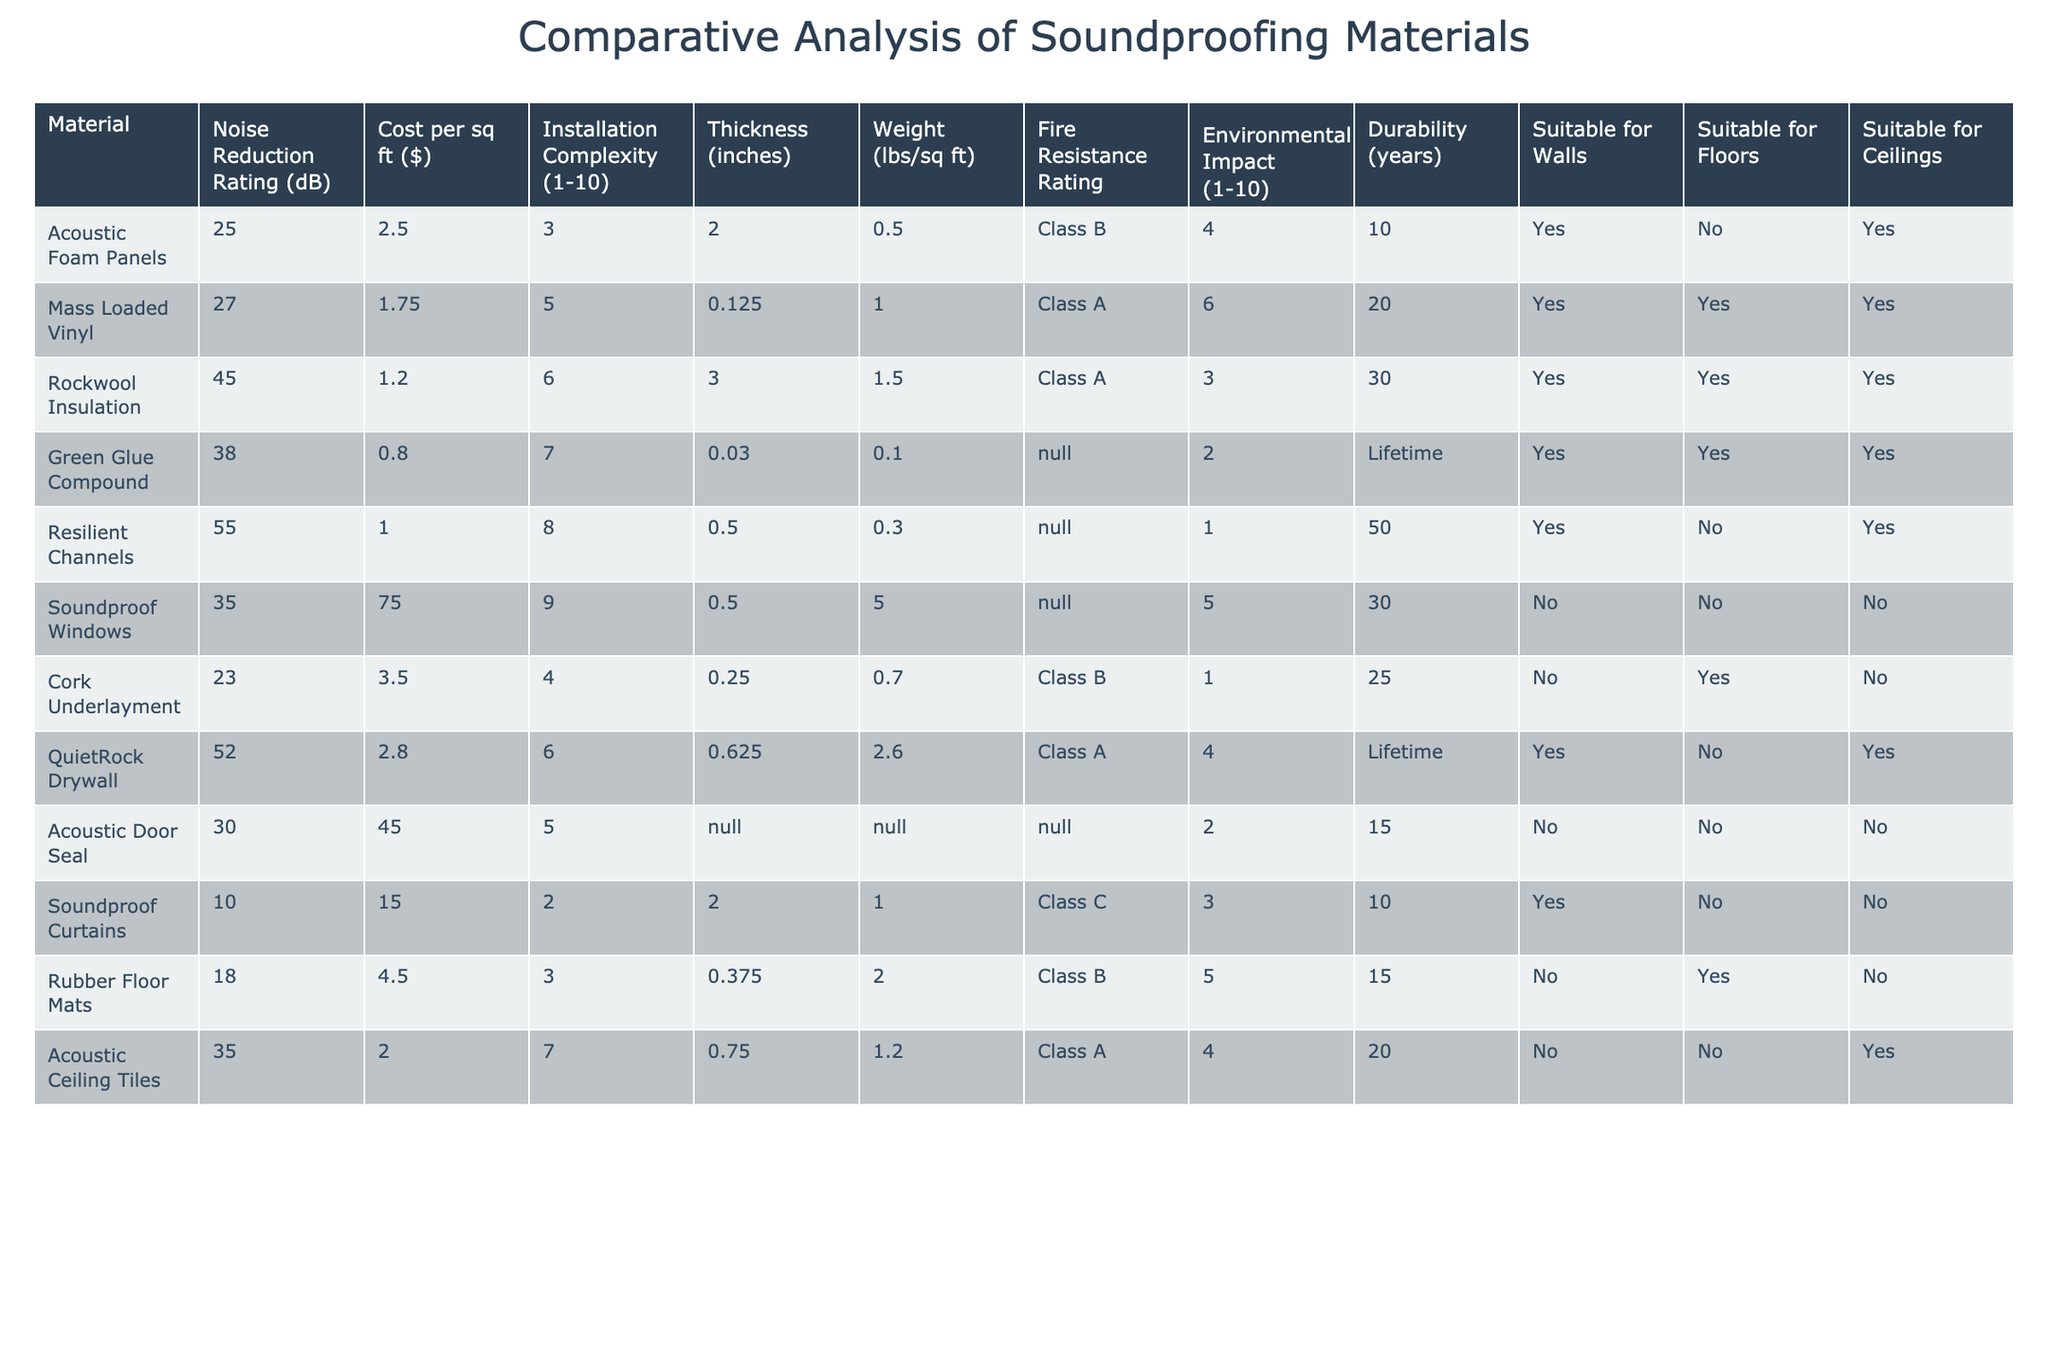What is the Noise Reduction Rating for Rockwool Insulation? The Noise Reduction Rating is listed directly in the table under Rockwool Insulation, which shows a value of 45 dB.
Answer: 45 dB Which material has the highest Noise Reduction Rating? By reviewing the Noise Reduction Rating column, Resilient Channels stands out with the highest rating of 55 dB compared to the other materials.
Answer: Resilient Channels What is the installation complexity rating for Mass Loaded Vinyl? The installation complexity is indicated in the table under Mass Loaded Vinyl, and it shows a rating of 5.
Answer: 5 How much does Soundproof Windows cost per square foot? The cost for Soundproof Windows is directly shown in the table, which lists the cost as $75.00 per square foot.
Answer: $75.00 Is Green Glue Compound suitable for floors? The table indicates whether the material is suitable for floors, and Green Glue Compound is marked as "Yes."
Answer: Yes What is the average Noise Reduction Rating of materials suitable for ceilings? The materials suitable for ceilings are Acoustic Foam Panels, Green Glue Compound, Resilient Channels, QuietRock Drywall, and Acoustic Ceiling Tiles. Their ratings (25, 38, 55, 52, 35) sum to 205, and the average is 205/5 = 41.
Answer: 41 Which material offers the best fire resistance? The table lists the fire resistance ratings, and both Rockwool Insulation and Mass Loaded Vinyl have a Class A rating.
Answer: Class A What is the total cost per square foot for the top three materials based on Noise Reduction Rating? The top three rated materials are Resilient Channels ($1.00), Rockwool Insulation ($1.20), and QuietRock Drywall ($2.80). The total cost is $1.00 + $1.20 + $2.80 = $5.00.
Answer: $5.00 How many materials have a fire resistance rating of Class A? The table indicates three materials with a Class A fire resistance rating: Mass Loaded Vinyl, Rockwool Insulation, and QuietRock Drywall.
Answer: 3 Is there any material that is suitable for both walls and floors? The table reveals that Mass Loaded Vinyl and Rockwool Insulation are suitable for both walls and floors.
Answer: Yes 